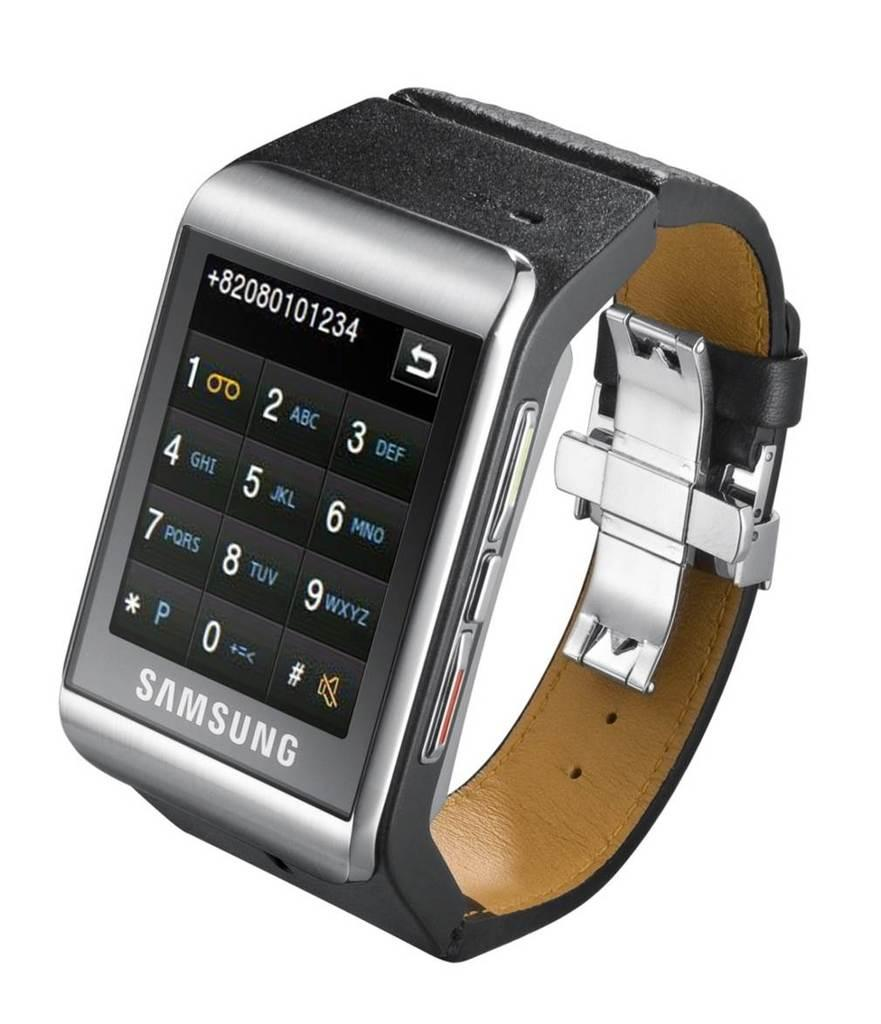<image>
Present a compact description of the photo's key features. A black smart watch says Samsung on the front. 